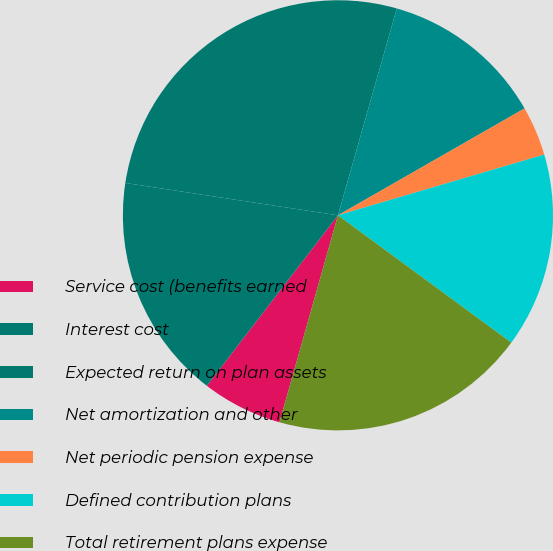<chart> <loc_0><loc_0><loc_500><loc_500><pie_chart><fcel>Service cost (benefits earned<fcel>Interest cost<fcel>Expected return on plan assets<fcel>Net amortization and other<fcel>Net periodic pension expense<fcel>Defined contribution plans<fcel>Total retirement plans expense<nl><fcel>6.05%<fcel>16.97%<fcel>27.01%<fcel>12.31%<fcel>3.72%<fcel>14.64%<fcel>19.3%<nl></chart> 